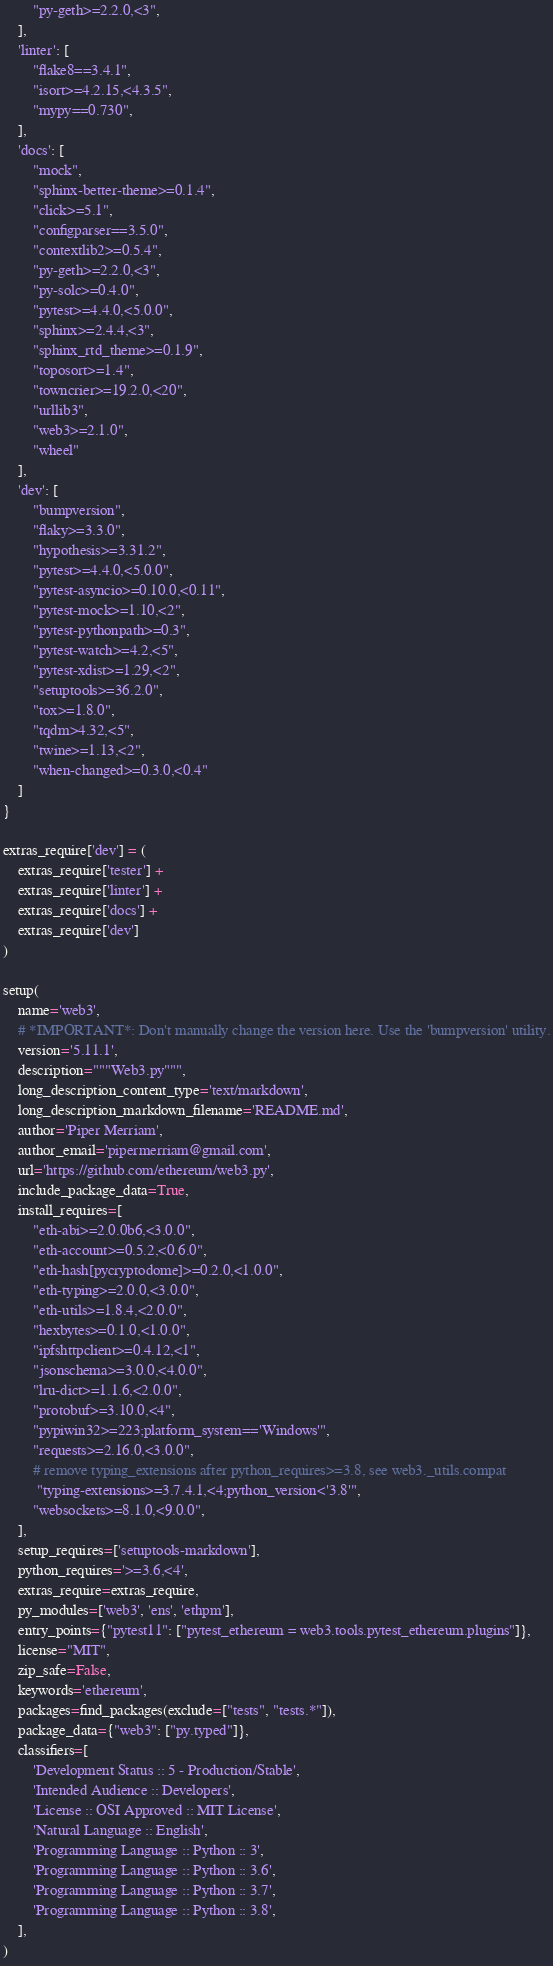Convert code to text. <code><loc_0><loc_0><loc_500><loc_500><_Python_>        "py-geth>=2.2.0,<3",
    ],
    'linter': [
        "flake8==3.4.1",
        "isort>=4.2.15,<4.3.5",
        "mypy==0.730",
    ],
    'docs': [
        "mock",
        "sphinx-better-theme>=0.1.4",
        "click>=5.1",
        "configparser==3.5.0",
        "contextlib2>=0.5.4",
        "py-geth>=2.2.0,<3",
        "py-solc>=0.4.0",
        "pytest>=4.4.0,<5.0.0",
        "sphinx>=2.4.4,<3",
        "sphinx_rtd_theme>=0.1.9",
        "toposort>=1.4",
        "towncrier>=19.2.0,<20",
        "urllib3",
        "web3>=2.1.0",
        "wheel"
    ],
    'dev': [
        "bumpversion",
        "flaky>=3.3.0",
        "hypothesis>=3.31.2",
        "pytest>=4.4.0,<5.0.0",
        "pytest-asyncio>=0.10.0,<0.11",
        "pytest-mock>=1.10,<2",
        "pytest-pythonpath>=0.3",
        "pytest-watch>=4.2,<5",
        "pytest-xdist>=1.29,<2",
        "setuptools>=36.2.0",
        "tox>=1.8.0",
        "tqdm>4.32,<5",
        "twine>=1.13,<2",
        "when-changed>=0.3.0,<0.4"
    ]
}

extras_require['dev'] = (
    extras_require['tester'] +
    extras_require['linter'] +
    extras_require['docs'] +
    extras_require['dev']
)

setup(
    name='web3',
    # *IMPORTANT*: Don't manually change the version here. Use the 'bumpversion' utility.
    version='5.11.1',
    description="""Web3.py""",
    long_description_content_type='text/markdown',
    long_description_markdown_filename='README.md',
    author='Piper Merriam',
    author_email='pipermerriam@gmail.com',
    url='https://github.com/ethereum/web3.py',
    include_package_data=True,
    install_requires=[
        "eth-abi>=2.0.0b6,<3.0.0",
        "eth-account>=0.5.2,<0.6.0",
        "eth-hash[pycryptodome]>=0.2.0,<1.0.0",
        "eth-typing>=2.0.0,<3.0.0",
        "eth-utils>=1.8.4,<2.0.0",
        "hexbytes>=0.1.0,<1.0.0",
        "ipfshttpclient>=0.4.12,<1",
        "jsonschema>=3.0.0,<4.0.0",
        "lru-dict>=1.1.6,<2.0.0",
        "protobuf>=3.10.0,<4",
        "pypiwin32>=223;platform_system=='Windows'",
        "requests>=2.16.0,<3.0.0",
        # remove typing_extensions after python_requires>=3.8, see web3._utils.compat
         "typing-extensions>=3.7.4.1,<4;python_version<'3.8'",
        "websockets>=8.1.0,<9.0.0",
    ],
    setup_requires=['setuptools-markdown'],
    python_requires='>=3.6,<4',
    extras_require=extras_require,
    py_modules=['web3', 'ens', 'ethpm'],
    entry_points={"pytest11": ["pytest_ethereum = web3.tools.pytest_ethereum.plugins"]},
    license="MIT",
    zip_safe=False,
    keywords='ethereum',
    packages=find_packages(exclude=["tests", "tests.*"]),
    package_data={"web3": ["py.typed"]},
    classifiers=[
        'Development Status :: 5 - Production/Stable',
        'Intended Audience :: Developers',
        'License :: OSI Approved :: MIT License',
        'Natural Language :: English',
        'Programming Language :: Python :: 3',
        'Programming Language :: Python :: 3.6',
        'Programming Language :: Python :: 3.7',
        'Programming Language :: Python :: 3.8',
    ],
)
</code> 